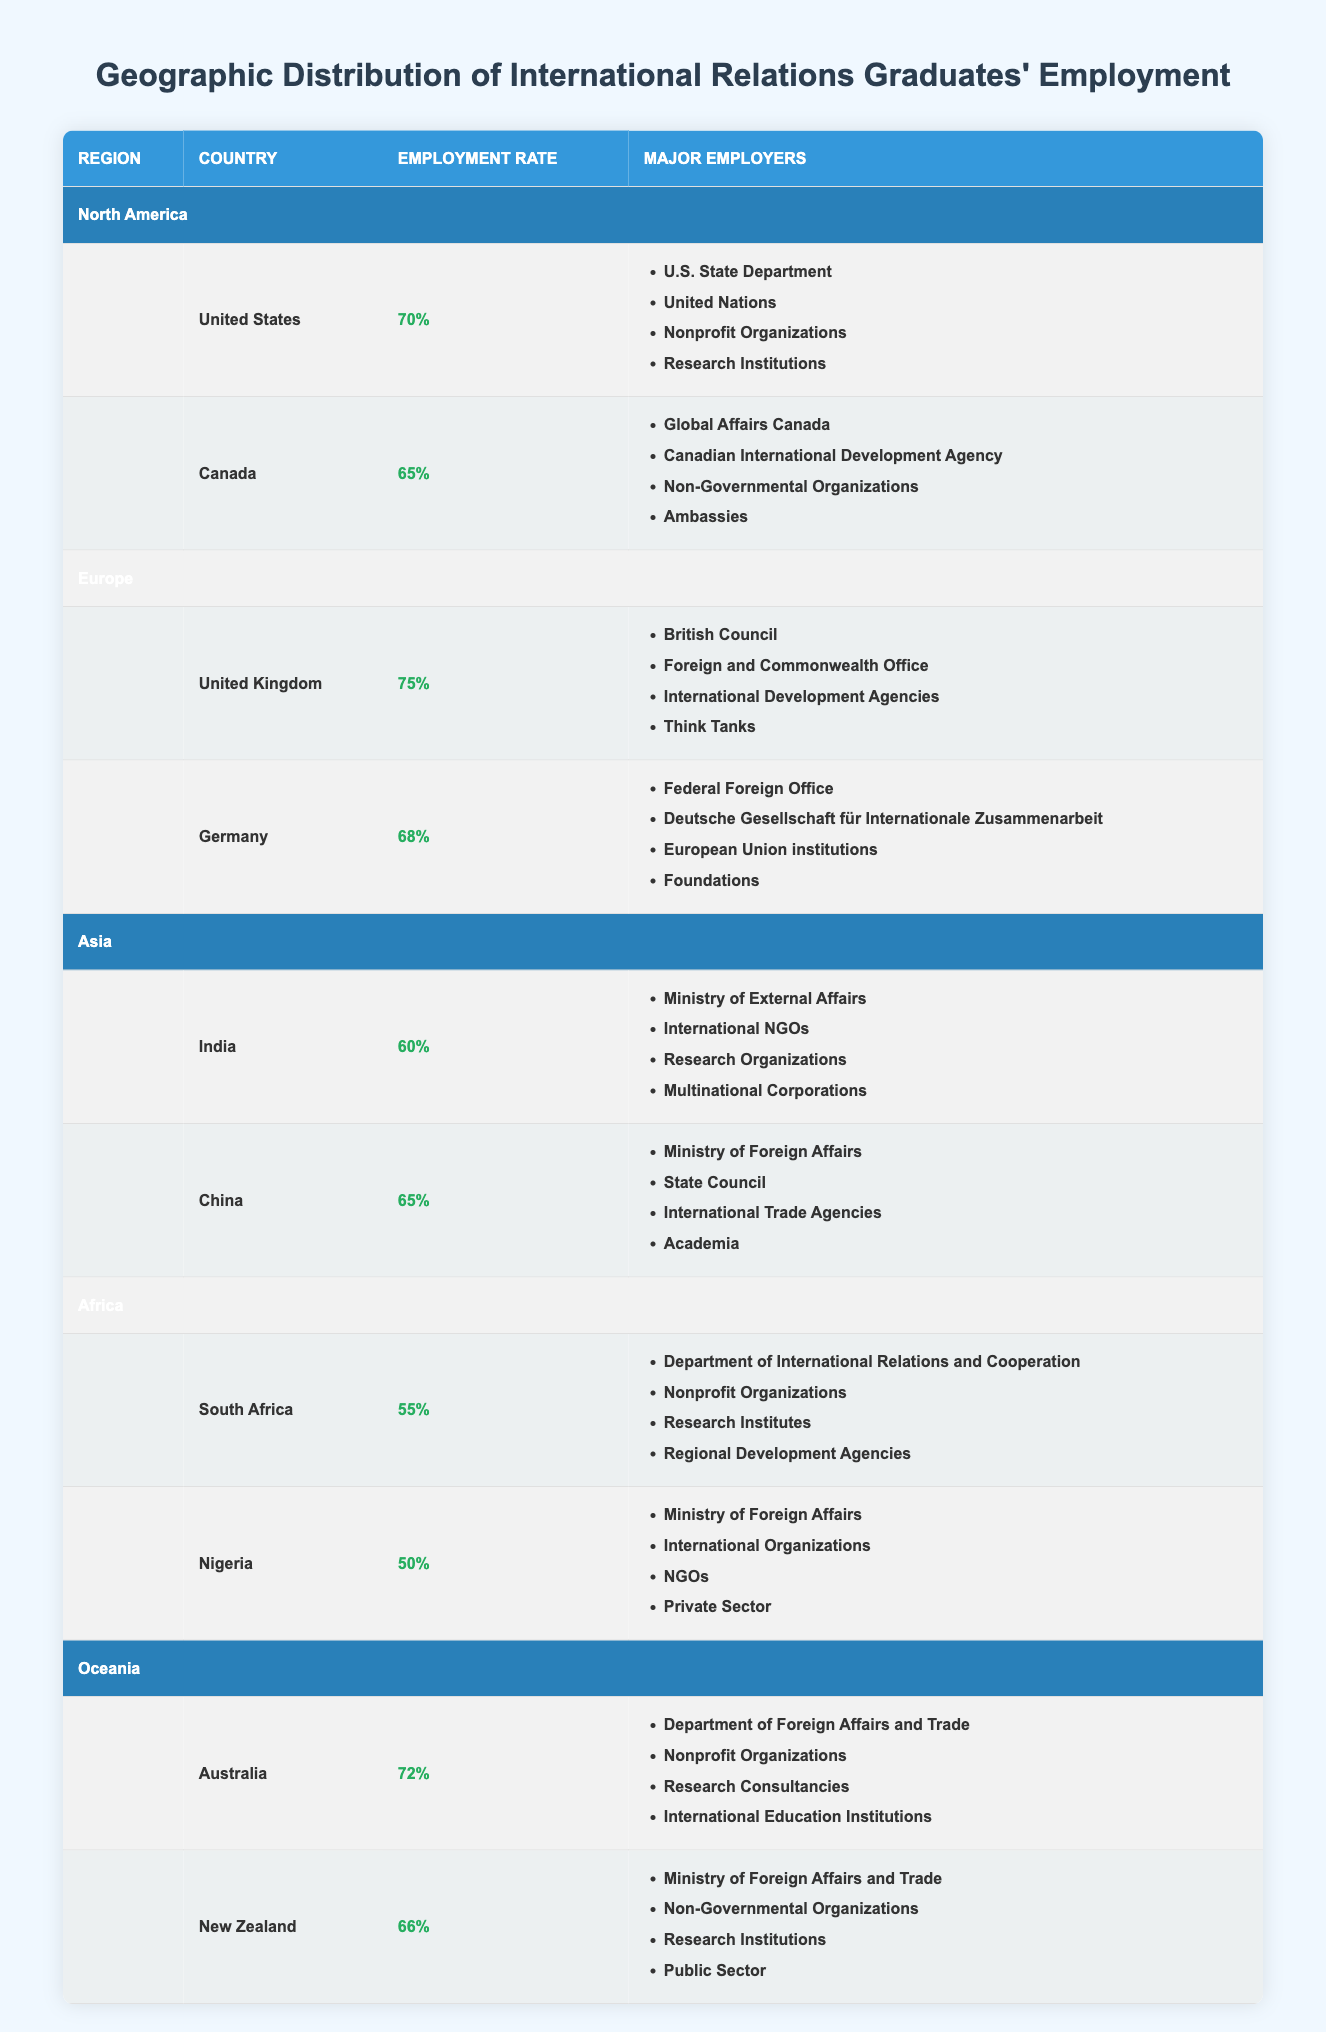What is the employment rate for international relations graduates in the United States? The employment rate for international relations graduates in the United States is explicitly stated in the table under the North America section. It is 70%.
Answer: 70% Which country in Europe has the highest employment rate for international relations graduates? By examining the employment rates listed for the United Kingdom (75%) and Germany (68%), it is evident that the United Kingdom has the highest employment rate for international relations graduates in Europe.
Answer: United Kingdom What are the major employers for international relations graduates in Canada? The table lists the major employers for international relations graduates in Canada, which include Global Affairs Canada, Canadian International Development Agency, Non-Governmental Organizations, and Ambassies.
Answer: Global Affairs Canada, Canadian International Development Agency, Non-Governmental Organizations, Ambassies What is the average employment rate of international relations graduates across all regions? To find the average employment rate, sum the employment rates (70 + 65 + 75 + 68 + 60 + 65 + 55 + 50 + 72 + 66) =  70 + 65 + 75 + 68 + 60 + 65 + 55 + 50 + 72 + 66 =  60 = 67.
Answer: 67% Is the employment rate for international relations graduates in South Africa higher than in Nigeria? The employment rate for South Africa is 55%, while Nigeria's is 50%. Since 55% is greater than 50%, the statement is true.
Answer: Yes Identify the country with the lowest employment rate for international relations graduates. Comparing the employment rates listed in the table for all countries, South Africa (55%) and Nigeria (50%) are the lowest. Nigeria, with 50%, has the lowest employment rate for international relations graduates.
Answer: Nigeria How much higher is the employment rate in Australia compared to that in South Africa? The employment rate in Australia is 72% and in South Africa it is 55%. To find the difference, subtract South Africa's rate from Australia's rate: 72% - 55% = 17%.
Answer: 17% What are the major employers for international relations graduates in China? The table indicates that the major employers for international relations graduates in China include the Ministry of Foreign Affairs, State Council, International Trade Agencies, and Academia.
Answer: Ministry of Foreign Affairs, State Council, International Trade Agencies, Academia Is it true that the employment rate for international relations graduates in Germany is above 70%? The employment rate for Germany is stated as 68%, which is less than 70%. Thus, the statement is false.
Answer: No 